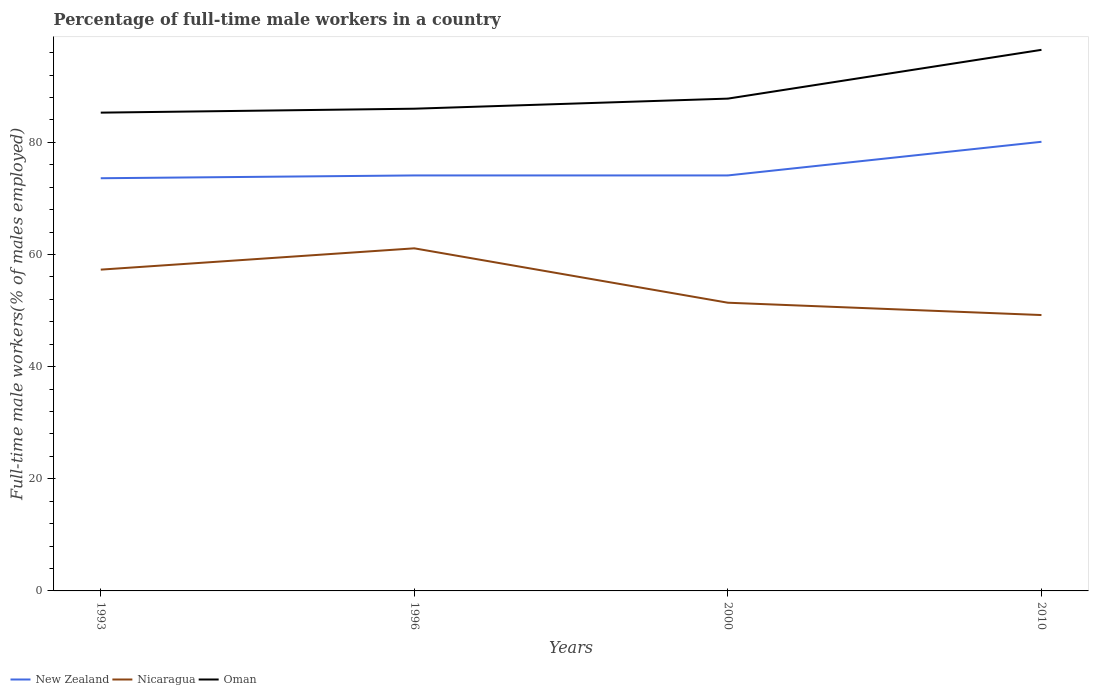Across all years, what is the maximum percentage of full-time male workers in Oman?
Provide a succinct answer. 85.3. In which year was the percentage of full-time male workers in Nicaragua maximum?
Ensure brevity in your answer.  2010. What is the difference between the highest and the second highest percentage of full-time male workers in Oman?
Offer a terse response. 11.2. What is the difference between the highest and the lowest percentage of full-time male workers in Oman?
Keep it short and to the point. 1. Is the percentage of full-time male workers in Oman strictly greater than the percentage of full-time male workers in New Zealand over the years?
Your answer should be very brief. No. What is the difference between two consecutive major ticks on the Y-axis?
Offer a very short reply. 20. Are the values on the major ticks of Y-axis written in scientific E-notation?
Offer a very short reply. No. How many legend labels are there?
Ensure brevity in your answer.  3. What is the title of the graph?
Give a very brief answer. Percentage of full-time male workers in a country. Does "Moldova" appear as one of the legend labels in the graph?
Your answer should be very brief. No. What is the label or title of the Y-axis?
Your answer should be very brief. Full-time male workers(% of males employed). What is the Full-time male workers(% of males employed) in New Zealand in 1993?
Your answer should be very brief. 73.6. What is the Full-time male workers(% of males employed) in Nicaragua in 1993?
Your answer should be compact. 57.3. What is the Full-time male workers(% of males employed) of Oman in 1993?
Your response must be concise. 85.3. What is the Full-time male workers(% of males employed) in New Zealand in 1996?
Offer a terse response. 74.1. What is the Full-time male workers(% of males employed) of Nicaragua in 1996?
Your answer should be compact. 61.1. What is the Full-time male workers(% of males employed) of New Zealand in 2000?
Keep it short and to the point. 74.1. What is the Full-time male workers(% of males employed) of Nicaragua in 2000?
Make the answer very short. 51.4. What is the Full-time male workers(% of males employed) of Oman in 2000?
Your answer should be very brief. 87.8. What is the Full-time male workers(% of males employed) of New Zealand in 2010?
Your response must be concise. 80.1. What is the Full-time male workers(% of males employed) of Nicaragua in 2010?
Provide a succinct answer. 49.2. What is the Full-time male workers(% of males employed) of Oman in 2010?
Offer a terse response. 96.5. Across all years, what is the maximum Full-time male workers(% of males employed) of New Zealand?
Provide a succinct answer. 80.1. Across all years, what is the maximum Full-time male workers(% of males employed) of Nicaragua?
Offer a terse response. 61.1. Across all years, what is the maximum Full-time male workers(% of males employed) in Oman?
Your answer should be compact. 96.5. Across all years, what is the minimum Full-time male workers(% of males employed) of New Zealand?
Offer a very short reply. 73.6. Across all years, what is the minimum Full-time male workers(% of males employed) in Nicaragua?
Give a very brief answer. 49.2. Across all years, what is the minimum Full-time male workers(% of males employed) of Oman?
Your answer should be very brief. 85.3. What is the total Full-time male workers(% of males employed) of New Zealand in the graph?
Provide a short and direct response. 301.9. What is the total Full-time male workers(% of males employed) of Nicaragua in the graph?
Your answer should be very brief. 219. What is the total Full-time male workers(% of males employed) in Oman in the graph?
Offer a terse response. 355.6. What is the difference between the Full-time male workers(% of males employed) in Nicaragua in 1993 and that in 1996?
Provide a short and direct response. -3.8. What is the difference between the Full-time male workers(% of males employed) of Oman in 1993 and that in 2000?
Provide a short and direct response. -2.5. What is the difference between the Full-time male workers(% of males employed) in Nicaragua in 1993 and that in 2010?
Offer a very short reply. 8.1. What is the difference between the Full-time male workers(% of males employed) of New Zealand in 1996 and that in 2010?
Your answer should be compact. -6. What is the difference between the Full-time male workers(% of males employed) of Nicaragua in 1996 and that in 2010?
Your response must be concise. 11.9. What is the difference between the Full-time male workers(% of males employed) in Oman in 1996 and that in 2010?
Offer a terse response. -10.5. What is the difference between the Full-time male workers(% of males employed) in Nicaragua in 2000 and that in 2010?
Offer a terse response. 2.2. What is the difference between the Full-time male workers(% of males employed) of New Zealand in 1993 and the Full-time male workers(% of males employed) of Oman in 1996?
Keep it short and to the point. -12.4. What is the difference between the Full-time male workers(% of males employed) of Nicaragua in 1993 and the Full-time male workers(% of males employed) of Oman in 1996?
Keep it short and to the point. -28.7. What is the difference between the Full-time male workers(% of males employed) of New Zealand in 1993 and the Full-time male workers(% of males employed) of Oman in 2000?
Offer a very short reply. -14.2. What is the difference between the Full-time male workers(% of males employed) in Nicaragua in 1993 and the Full-time male workers(% of males employed) in Oman in 2000?
Keep it short and to the point. -30.5. What is the difference between the Full-time male workers(% of males employed) in New Zealand in 1993 and the Full-time male workers(% of males employed) in Nicaragua in 2010?
Your answer should be compact. 24.4. What is the difference between the Full-time male workers(% of males employed) in New Zealand in 1993 and the Full-time male workers(% of males employed) in Oman in 2010?
Give a very brief answer. -22.9. What is the difference between the Full-time male workers(% of males employed) in Nicaragua in 1993 and the Full-time male workers(% of males employed) in Oman in 2010?
Make the answer very short. -39.2. What is the difference between the Full-time male workers(% of males employed) of New Zealand in 1996 and the Full-time male workers(% of males employed) of Nicaragua in 2000?
Ensure brevity in your answer.  22.7. What is the difference between the Full-time male workers(% of males employed) in New Zealand in 1996 and the Full-time male workers(% of males employed) in Oman in 2000?
Your answer should be very brief. -13.7. What is the difference between the Full-time male workers(% of males employed) of Nicaragua in 1996 and the Full-time male workers(% of males employed) of Oman in 2000?
Your response must be concise. -26.7. What is the difference between the Full-time male workers(% of males employed) in New Zealand in 1996 and the Full-time male workers(% of males employed) in Nicaragua in 2010?
Your answer should be compact. 24.9. What is the difference between the Full-time male workers(% of males employed) in New Zealand in 1996 and the Full-time male workers(% of males employed) in Oman in 2010?
Make the answer very short. -22.4. What is the difference between the Full-time male workers(% of males employed) in Nicaragua in 1996 and the Full-time male workers(% of males employed) in Oman in 2010?
Make the answer very short. -35.4. What is the difference between the Full-time male workers(% of males employed) of New Zealand in 2000 and the Full-time male workers(% of males employed) of Nicaragua in 2010?
Ensure brevity in your answer.  24.9. What is the difference between the Full-time male workers(% of males employed) of New Zealand in 2000 and the Full-time male workers(% of males employed) of Oman in 2010?
Provide a succinct answer. -22.4. What is the difference between the Full-time male workers(% of males employed) of Nicaragua in 2000 and the Full-time male workers(% of males employed) of Oman in 2010?
Provide a short and direct response. -45.1. What is the average Full-time male workers(% of males employed) of New Zealand per year?
Make the answer very short. 75.47. What is the average Full-time male workers(% of males employed) in Nicaragua per year?
Keep it short and to the point. 54.75. What is the average Full-time male workers(% of males employed) in Oman per year?
Offer a very short reply. 88.9. In the year 1993, what is the difference between the Full-time male workers(% of males employed) of Nicaragua and Full-time male workers(% of males employed) of Oman?
Keep it short and to the point. -28. In the year 1996, what is the difference between the Full-time male workers(% of males employed) in New Zealand and Full-time male workers(% of males employed) in Nicaragua?
Offer a terse response. 13. In the year 1996, what is the difference between the Full-time male workers(% of males employed) in Nicaragua and Full-time male workers(% of males employed) in Oman?
Make the answer very short. -24.9. In the year 2000, what is the difference between the Full-time male workers(% of males employed) in New Zealand and Full-time male workers(% of males employed) in Nicaragua?
Keep it short and to the point. 22.7. In the year 2000, what is the difference between the Full-time male workers(% of males employed) of New Zealand and Full-time male workers(% of males employed) of Oman?
Provide a succinct answer. -13.7. In the year 2000, what is the difference between the Full-time male workers(% of males employed) of Nicaragua and Full-time male workers(% of males employed) of Oman?
Provide a short and direct response. -36.4. In the year 2010, what is the difference between the Full-time male workers(% of males employed) in New Zealand and Full-time male workers(% of males employed) in Nicaragua?
Provide a short and direct response. 30.9. In the year 2010, what is the difference between the Full-time male workers(% of males employed) in New Zealand and Full-time male workers(% of males employed) in Oman?
Make the answer very short. -16.4. In the year 2010, what is the difference between the Full-time male workers(% of males employed) in Nicaragua and Full-time male workers(% of males employed) in Oman?
Make the answer very short. -47.3. What is the ratio of the Full-time male workers(% of males employed) of New Zealand in 1993 to that in 1996?
Provide a short and direct response. 0.99. What is the ratio of the Full-time male workers(% of males employed) in Nicaragua in 1993 to that in 1996?
Ensure brevity in your answer.  0.94. What is the ratio of the Full-time male workers(% of males employed) in Oman in 1993 to that in 1996?
Provide a succinct answer. 0.99. What is the ratio of the Full-time male workers(% of males employed) of New Zealand in 1993 to that in 2000?
Ensure brevity in your answer.  0.99. What is the ratio of the Full-time male workers(% of males employed) in Nicaragua in 1993 to that in 2000?
Make the answer very short. 1.11. What is the ratio of the Full-time male workers(% of males employed) in Oman in 1993 to that in 2000?
Provide a short and direct response. 0.97. What is the ratio of the Full-time male workers(% of males employed) in New Zealand in 1993 to that in 2010?
Offer a very short reply. 0.92. What is the ratio of the Full-time male workers(% of males employed) of Nicaragua in 1993 to that in 2010?
Make the answer very short. 1.16. What is the ratio of the Full-time male workers(% of males employed) of Oman in 1993 to that in 2010?
Provide a short and direct response. 0.88. What is the ratio of the Full-time male workers(% of males employed) of New Zealand in 1996 to that in 2000?
Keep it short and to the point. 1. What is the ratio of the Full-time male workers(% of males employed) in Nicaragua in 1996 to that in 2000?
Your answer should be very brief. 1.19. What is the ratio of the Full-time male workers(% of males employed) of Oman in 1996 to that in 2000?
Keep it short and to the point. 0.98. What is the ratio of the Full-time male workers(% of males employed) in New Zealand in 1996 to that in 2010?
Keep it short and to the point. 0.93. What is the ratio of the Full-time male workers(% of males employed) of Nicaragua in 1996 to that in 2010?
Provide a short and direct response. 1.24. What is the ratio of the Full-time male workers(% of males employed) in Oman in 1996 to that in 2010?
Keep it short and to the point. 0.89. What is the ratio of the Full-time male workers(% of males employed) in New Zealand in 2000 to that in 2010?
Provide a succinct answer. 0.93. What is the ratio of the Full-time male workers(% of males employed) in Nicaragua in 2000 to that in 2010?
Provide a short and direct response. 1.04. What is the ratio of the Full-time male workers(% of males employed) of Oman in 2000 to that in 2010?
Give a very brief answer. 0.91. What is the difference between the highest and the lowest Full-time male workers(% of males employed) in New Zealand?
Provide a short and direct response. 6.5. What is the difference between the highest and the lowest Full-time male workers(% of males employed) of Nicaragua?
Provide a short and direct response. 11.9. What is the difference between the highest and the lowest Full-time male workers(% of males employed) in Oman?
Ensure brevity in your answer.  11.2. 